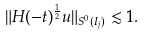<formula> <loc_0><loc_0><loc_500><loc_500>\| H ( - t ) ^ { \frac { 1 } { 2 } } u \| _ { S ^ { 0 } ( I _ { j } ) } \lesssim 1 .</formula> 